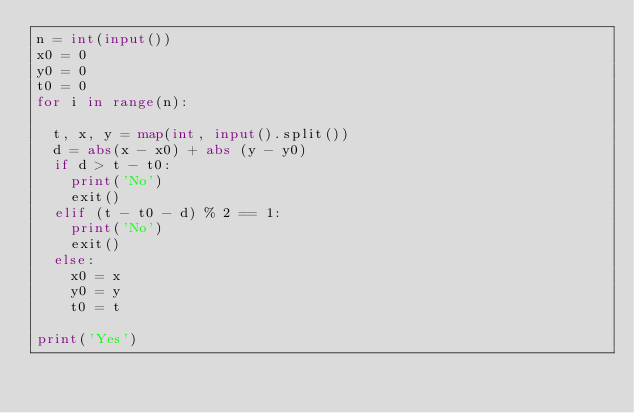<code> <loc_0><loc_0><loc_500><loc_500><_Python_>n = int(input())
x0 = 0
y0 = 0
t0 = 0
for i in range(n):
  
  t, x, y = map(int, input().split())
  d = abs(x - x0) + abs (y - y0)
  if d > t - t0:
    print('No')
    exit()
  elif (t - t0 - d) % 2 == 1:
    print('No')
    exit()
  else:
    x0 = x
    y0 = y
    t0 = t

print('Yes')</code> 